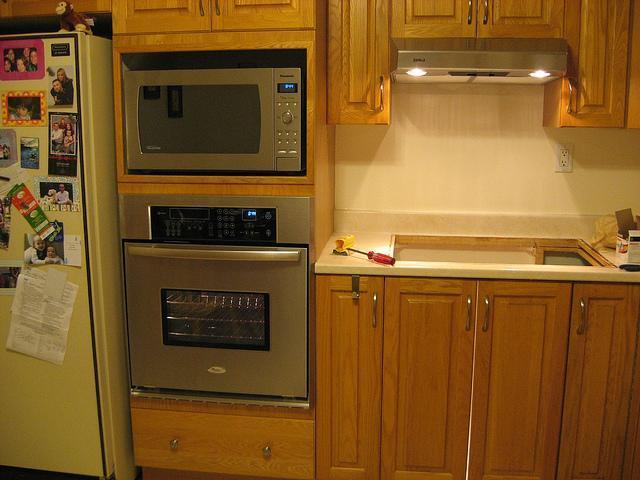How many ovens are there?
Give a very brief answer. 1. How many laptops are on?
Give a very brief answer. 0. 